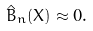Convert formula to latex. <formula><loc_0><loc_0><loc_500><loc_500>\hat { B } _ { n } ( X ) \approx 0 .</formula> 